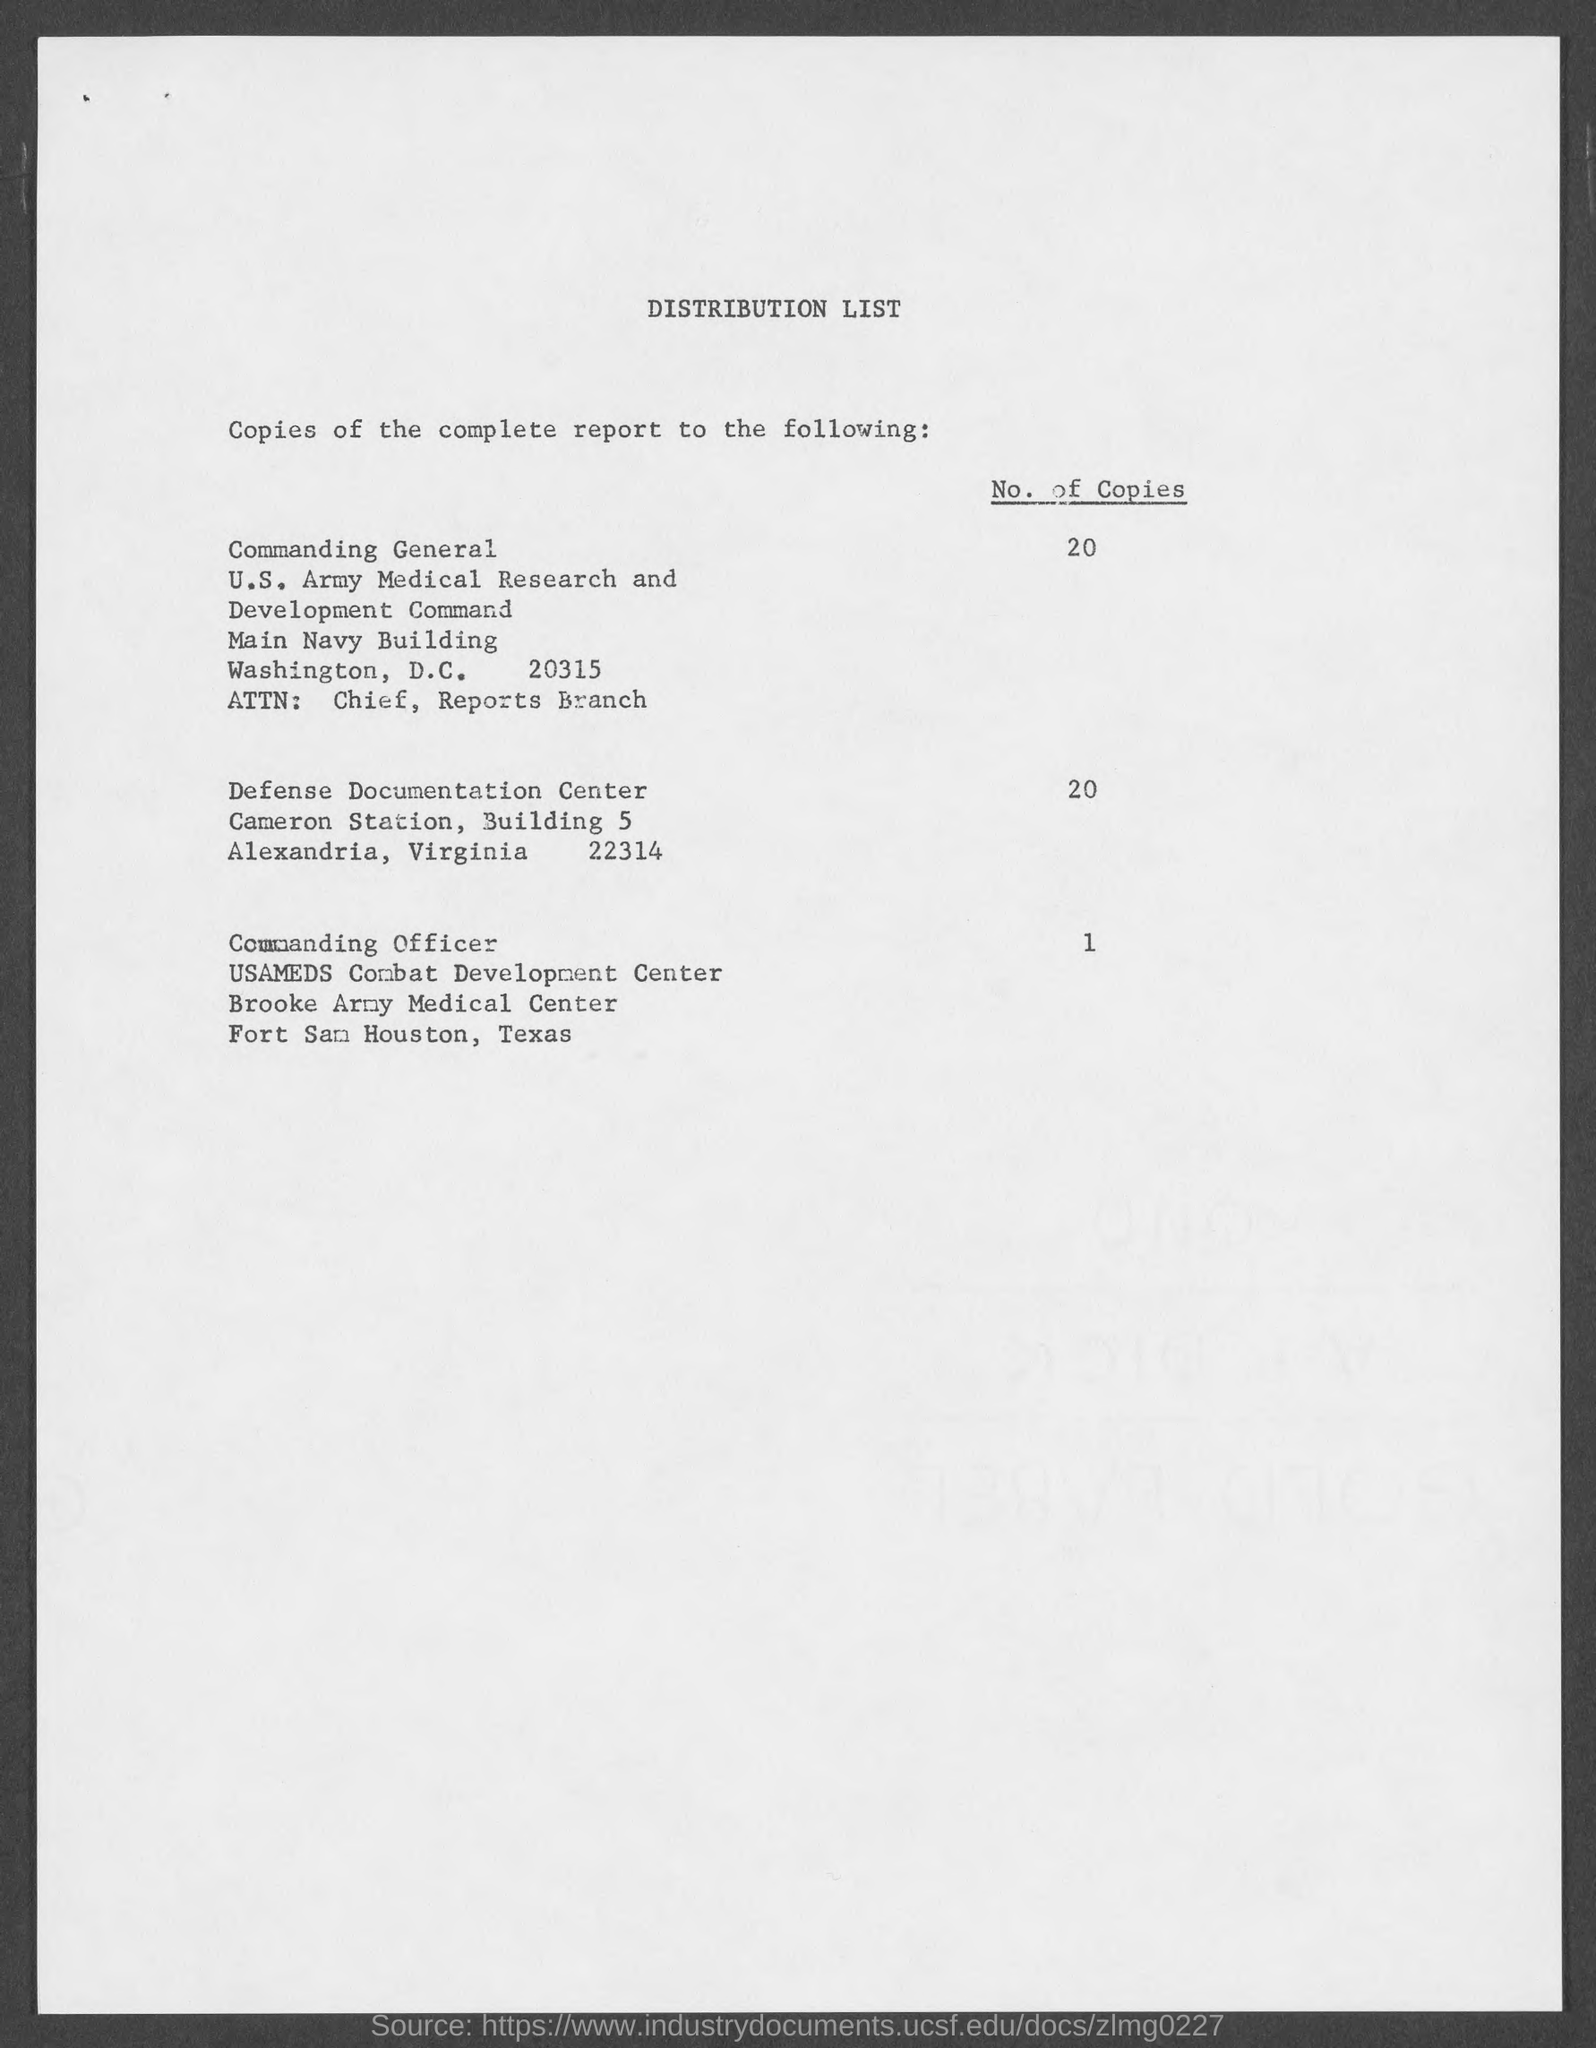How many copies of the complete report are distributed to the Commanding General?
Your answer should be very brief. 20. What is the no of copies of the complete report distributed to Defense Documentation Center?
Provide a succinct answer. 20. How many copies of the complete report are distributed to the Commanding Officer?
Keep it short and to the point. 1. What is the title of the document?
Provide a short and direct response. DISTRIBUTION LIST. 